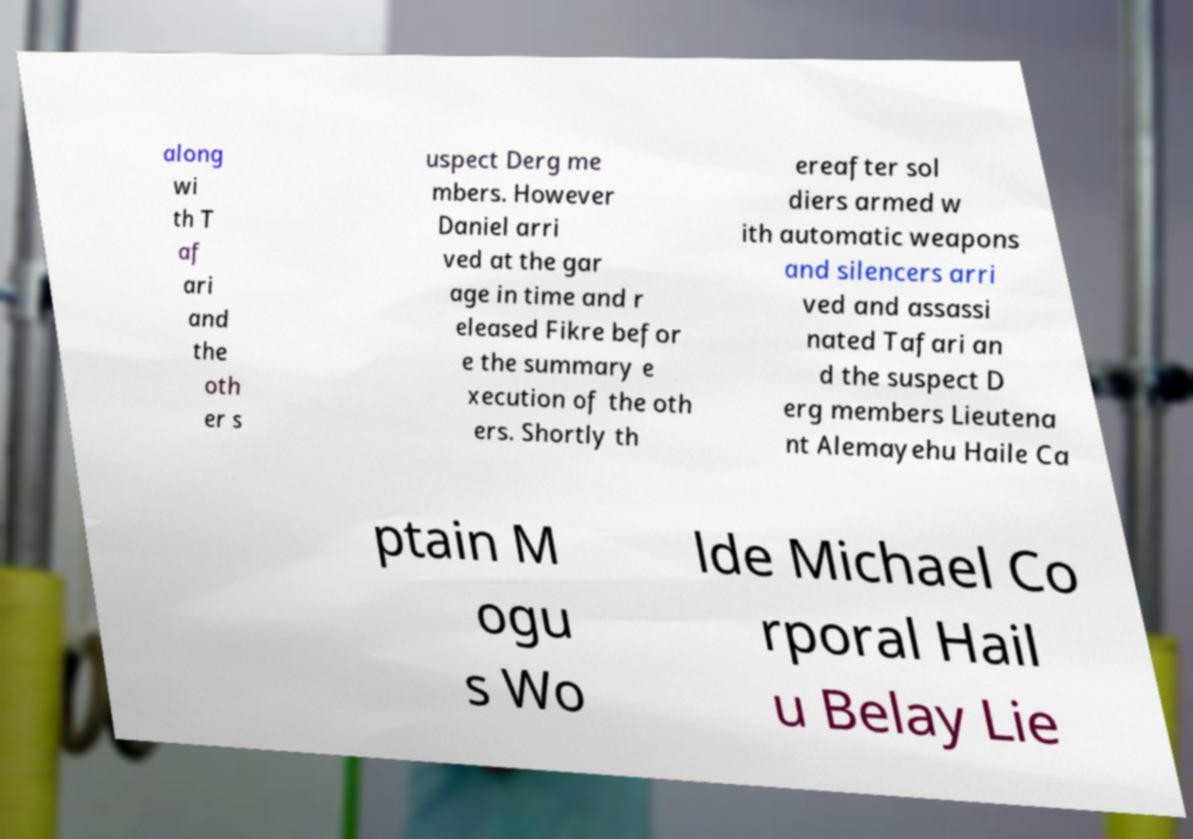What messages or text are displayed in this image? I need them in a readable, typed format. along wi th T af ari and the oth er s uspect Derg me mbers. However Daniel arri ved at the gar age in time and r eleased Fikre befor e the summary e xecution of the oth ers. Shortly th ereafter sol diers armed w ith automatic weapons and silencers arri ved and assassi nated Tafari an d the suspect D erg members Lieutena nt Alemayehu Haile Ca ptain M ogu s Wo lde Michael Co rporal Hail u Belay Lie 